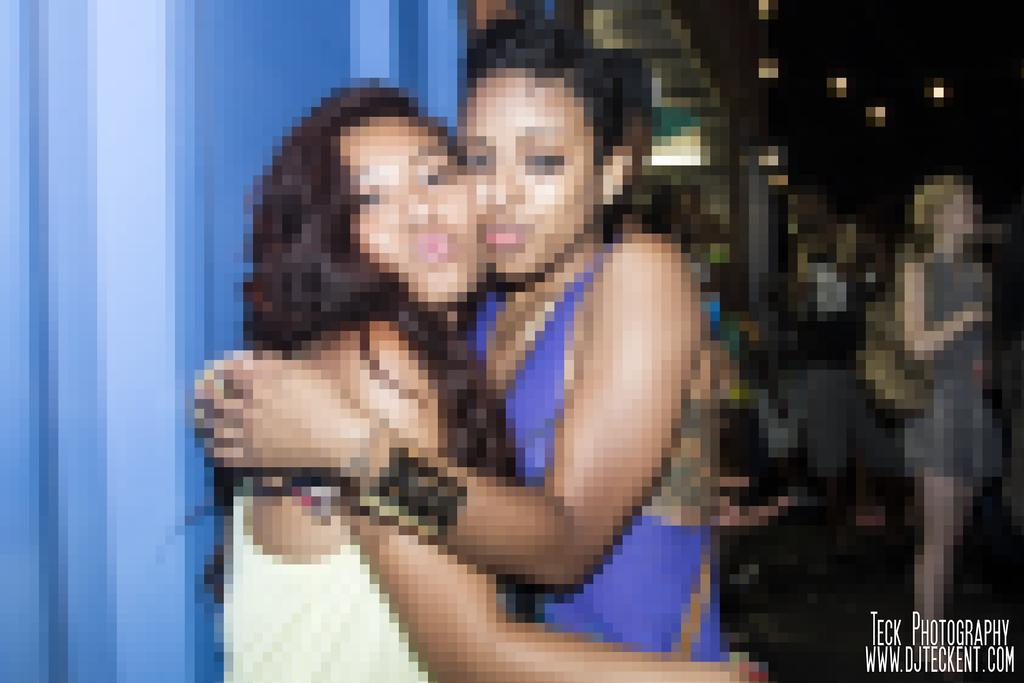How many people are in the image? There are two girls in the image. What are the girls doing in the image? The girls are standing and hugging each other. What type of insurance policy do the girls have in the image? There is no mention of insurance in the image, as it features two girls standing and hugging each other. 